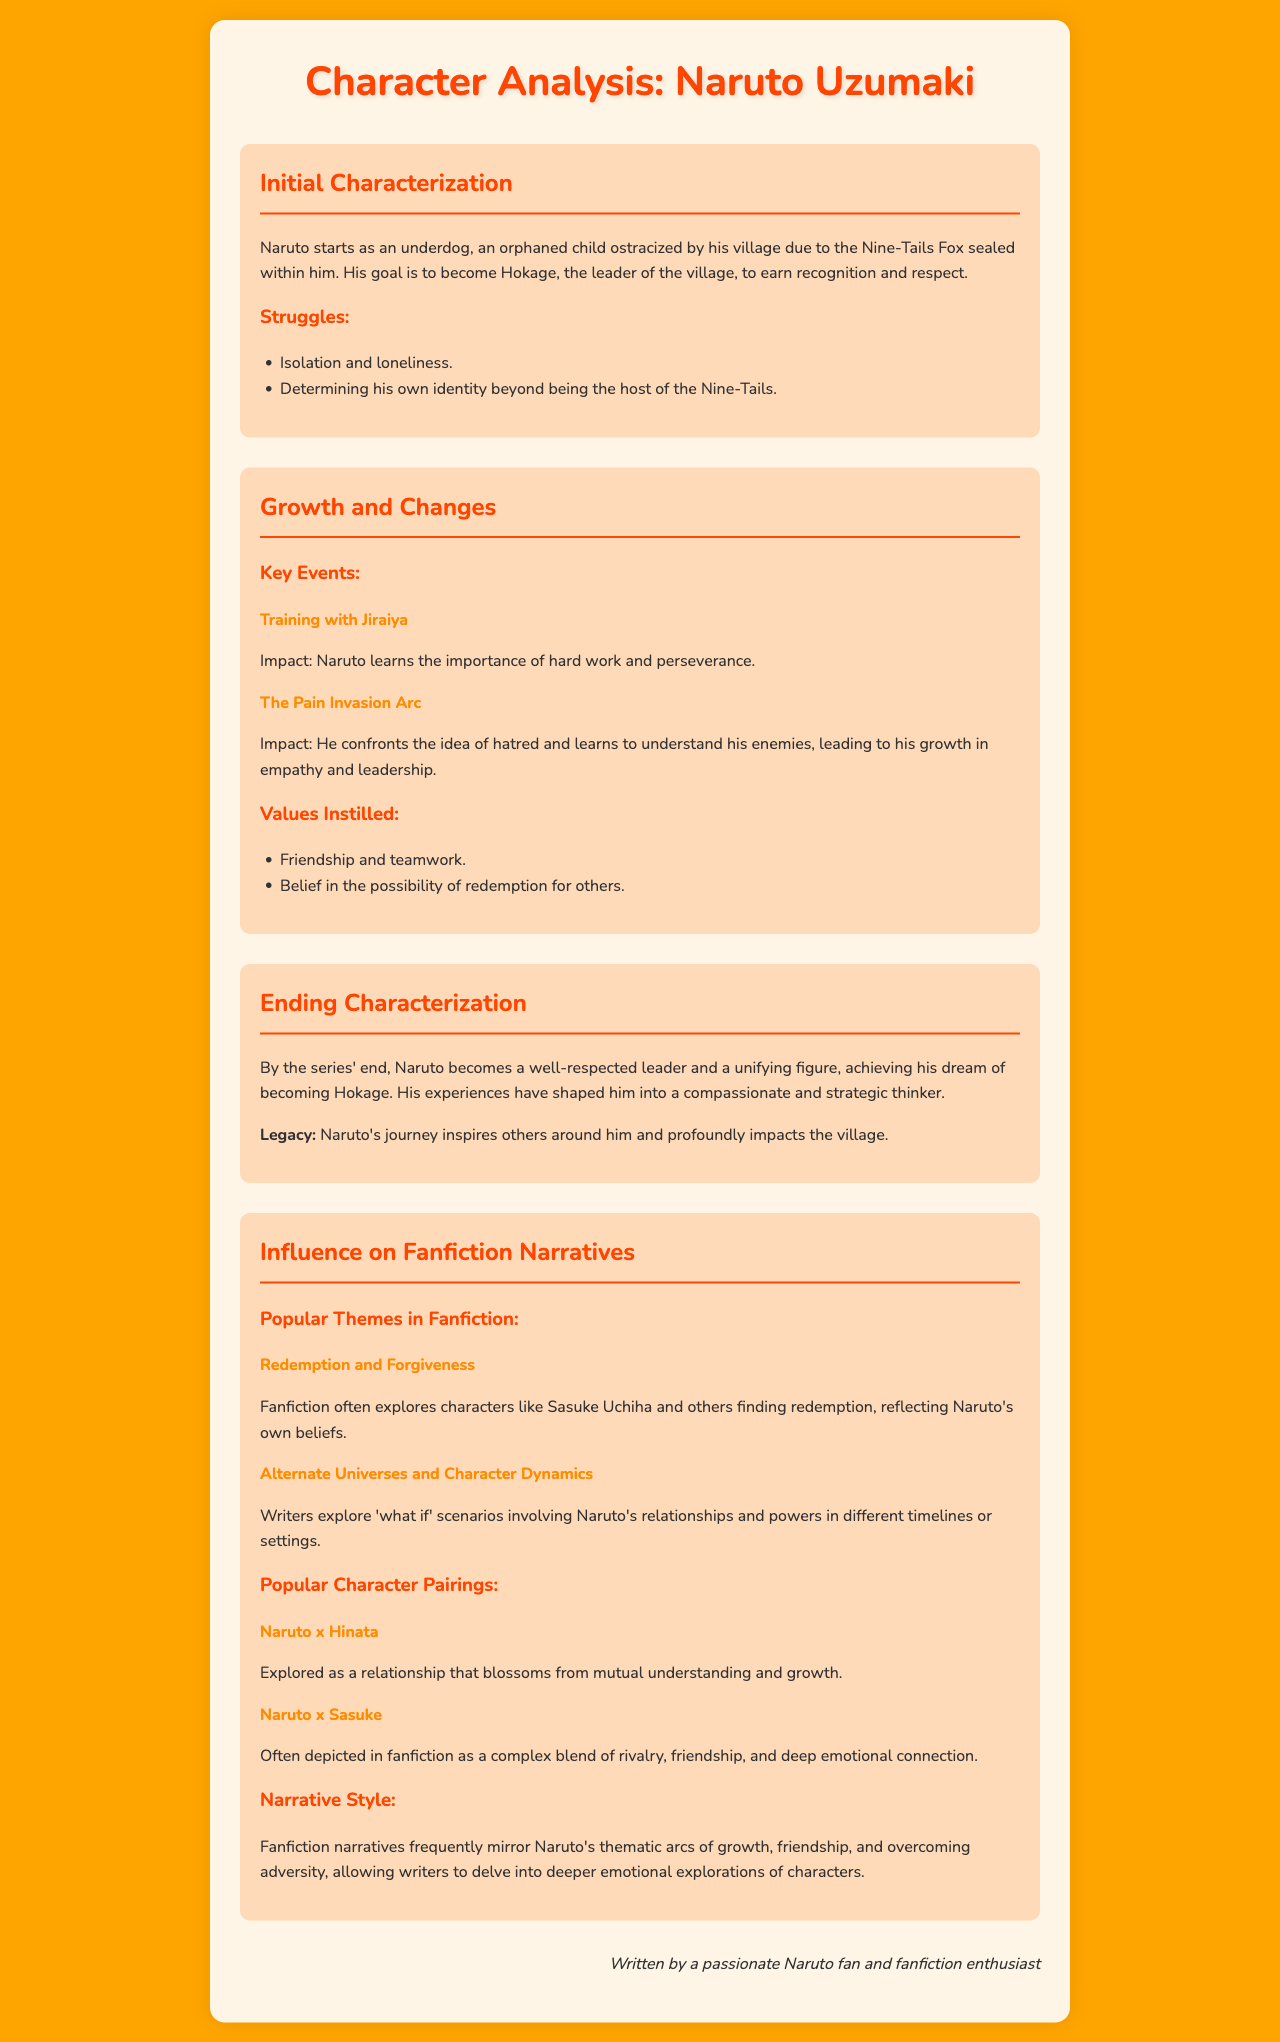What is Naruto's dream? Naruto's dream is to become Hokage, the leader of the village, to earn recognition and respect.
Answer: Hokage Who trained Naruto during his growth? Naruto trained with Jiraiya, which impacted his understanding of hard work and perseverance.
Answer: Jiraiya What key theme do fanfictions often explore related to Sasuke Uchiha? Fanfictions often explore the theme of redemption and forgiveness regarding Sasuke Uchiha.
Answer: Redemption and Forgiveness What is Naruto's final characterization in the series? By the series' end, Naruto becomes a well-respected leader and a unifying figure.
Answer: Well-respected leader Which character pairing is described as blossoming from mutual understanding? The pairing of Naruto and Hinata is explored as blossoming from mutual understanding and growth.
Answer: Naruto x Hinata How did Naruto's experiences impact his legacy? Naruto's experiences shaped him into a compassionate and strategic thinker, profoundly impacting the village.
Answer: Profoundly impacts the village What color is the background of the document? The background color of the document is orange.
Answer: Orange What is a popular narrative style in fanfiction based on Naruto? Fanfiction narratives frequently mirror Naruto's thematic arcs of growth, friendship, and overcoming adversity.
Answer: Thematic arcs of growth What does Naruto begin as in the series? Naruto starts as an underdog, an orphaned child ostracized by his village.
Answer: Underdog 